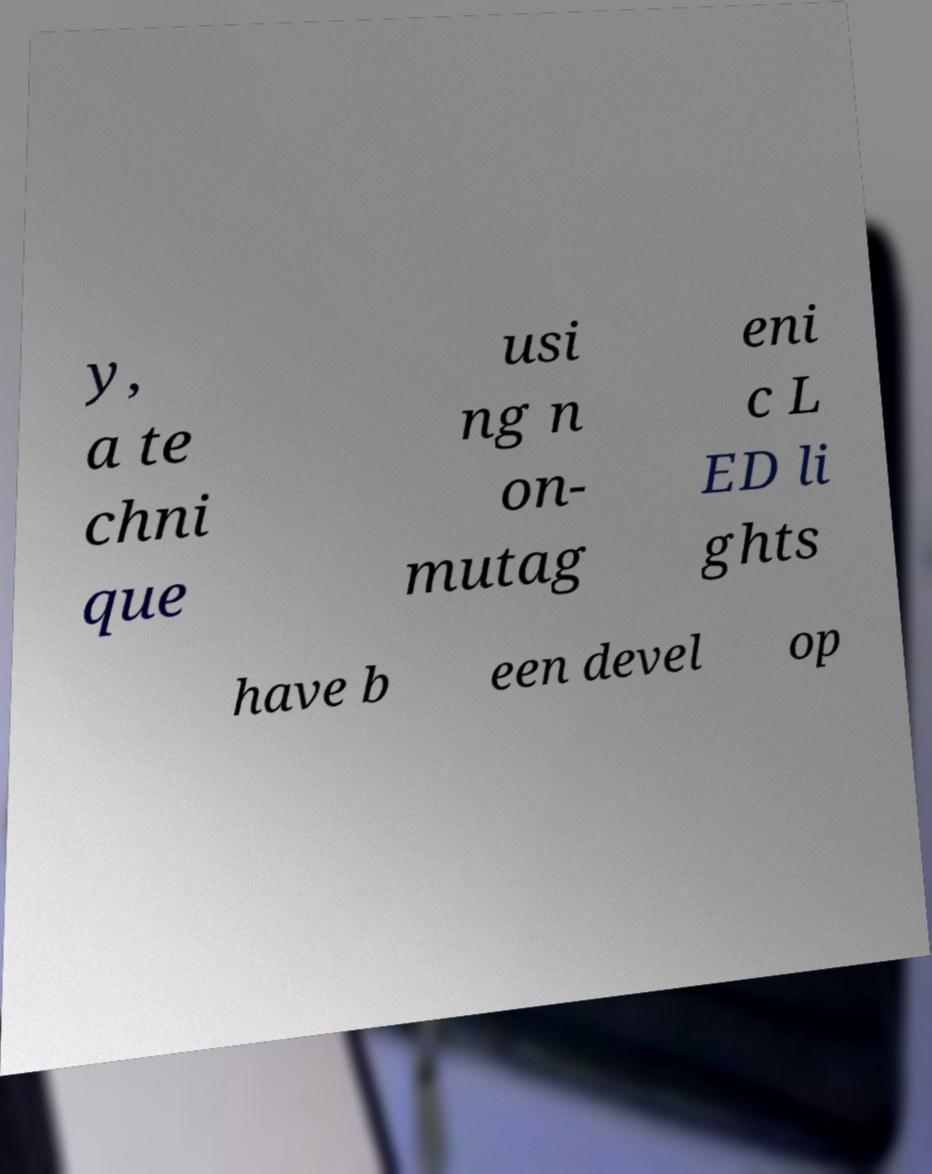Please identify and transcribe the text found in this image. y, a te chni que usi ng n on- mutag eni c L ED li ghts have b een devel op 